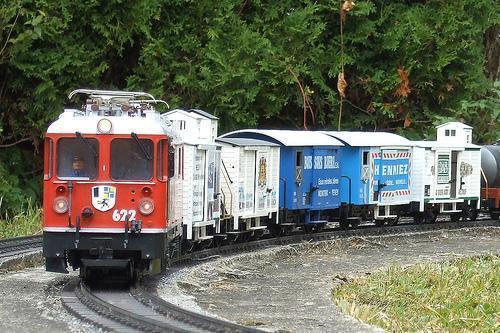How many trains are there?
Give a very brief answer. 1. How many tracks are there?
Give a very brief answer. 2. 